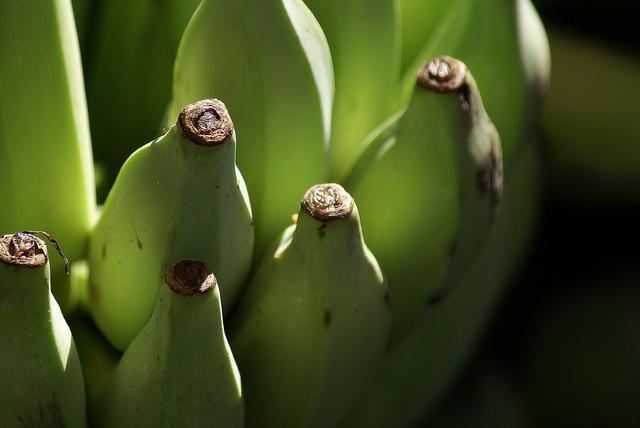How many bananas can be seen?
Give a very brief answer. 8. How many black umbrellas are there?
Give a very brief answer. 0. 